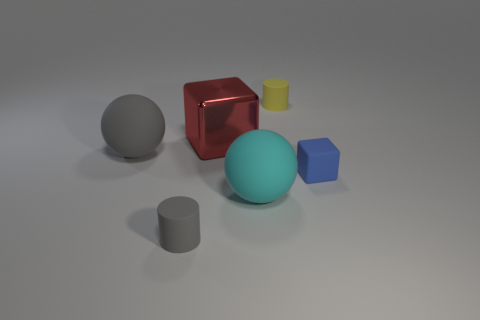Which objects in the image appear to have a shiny surface? The red cube and the gray sphere exhibit shiny surfaces, indicating that they may be made from materials like polished metal or plastic. 